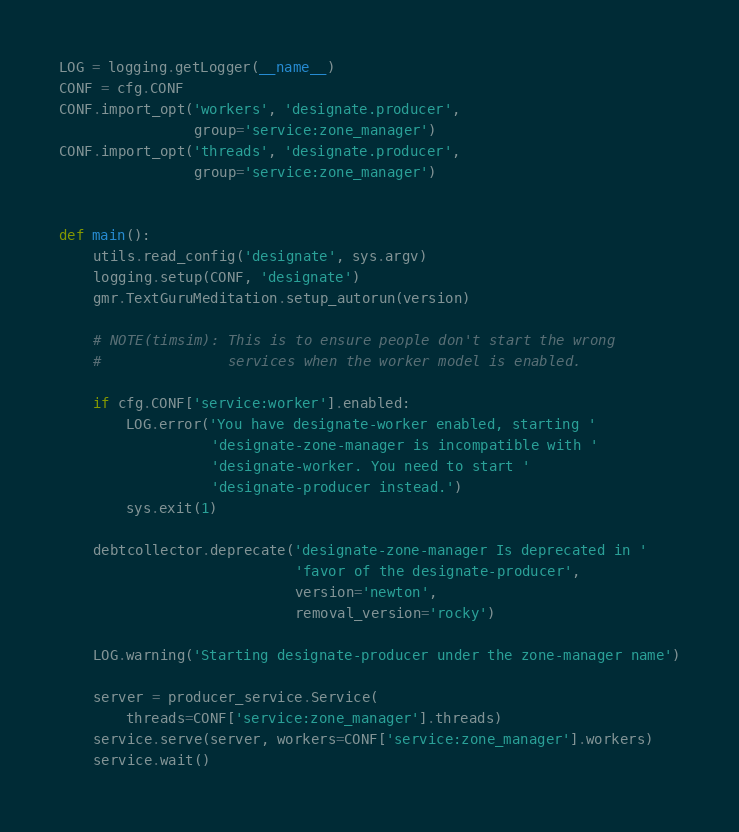Convert code to text. <code><loc_0><loc_0><loc_500><loc_500><_Python_>

LOG = logging.getLogger(__name__)
CONF = cfg.CONF
CONF.import_opt('workers', 'designate.producer',
                group='service:zone_manager')
CONF.import_opt('threads', 'designate.producer',
                group='service:zone_manager')


def main():
    utils.read_config('designate', sys.argv)
    logging.setup(CONF, 'designate')
    gmr.TextGuruMeditation.setup_autorun(version)

    # NOTE(timsim): This is to ensure people don't start the wrong
    #               services when the worker model is enabled.

    if cfg.CONF['service:worker'].enabled:
        LOG.error('You have designate-worker enabled, starting '
                  'designate-zone-manager is incompatible with '
                  'designate-worker. You need to start '
                  'designate-producer instead.')
        sys.exit(1)

    debtcollector.deprecate('designate-zone-manager Is deprecated in '
                            'favor of the designate-producer',
                            version='newton',
                            removal_version='rocky')

    LOG.warning('Starting designate-producer under the zone-manager name')

    server = producer_service.Service(
        threads=CONF['service:zone_manager'].threads)
    service.serve(server, workers=CONF['service:zone_manager'].workers)
    service.wait()
</code> 